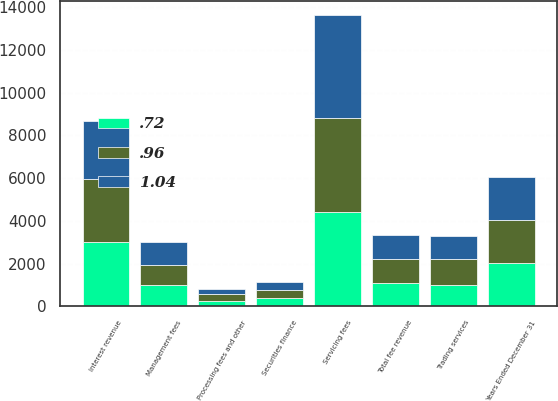<chart> <loc_0><loc_0><loc_500><loc_500><stacked_bar_chart><ecel><fcel>Years Ended December 31<fcel>Servicing fees<fcel>Management fees<fcel>Trading services<fcel>Securities finance<fcel>Processing fees and other<fcel>Total fee revenue<fcel>Interest revenue<nl><fcel>1.04<fcel>2013<fcel>4819<fcel>1106<fcel>1061<fcel>359<fcel>245<fcel>1106<fcel>2714<nl><fcel>0.72<fcel>2012<fcel>4414<fcel>993<fcel>1010<fcel>405<fcel>266<fcel>1106<fcel>3014<nl><fcel>0.96<fcel>2011<fcel>4382<fcel>917<fcel>1220<fcel>378<fcel>297<fcel>1106<fcel>2946<nl></chart> 